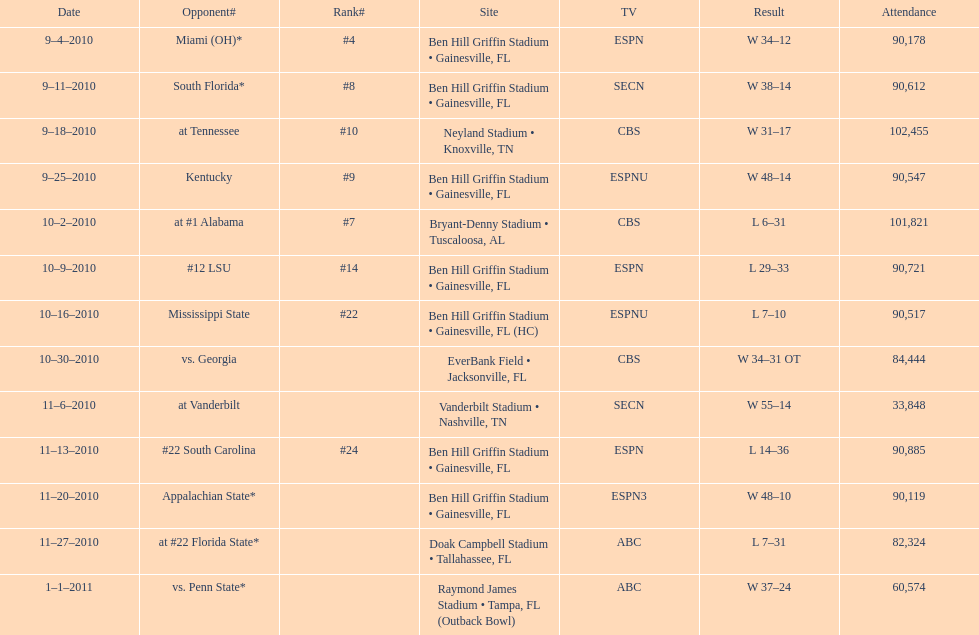During the 2010/2011 season, on which tv network were the most games aired? ESPN. 